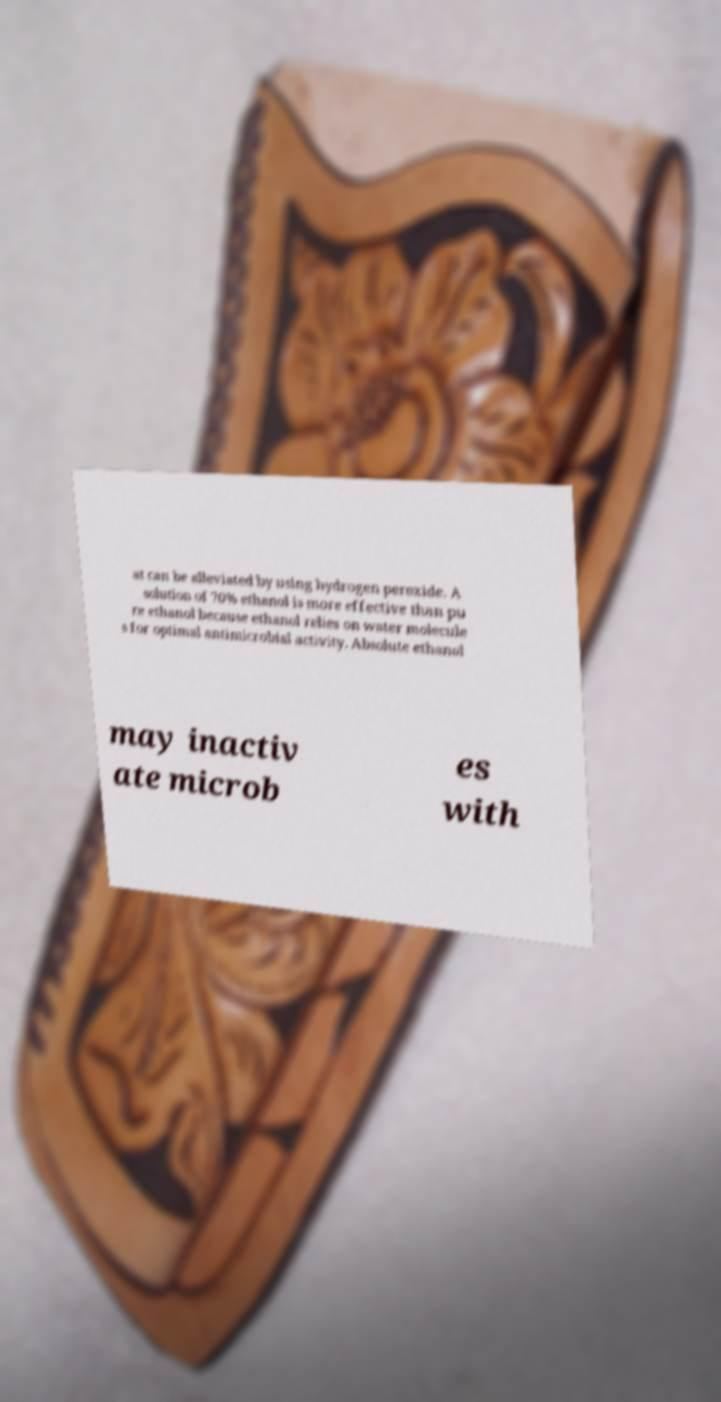Please identify and transcribe the text found in this image. at can be alleviated by using hydrogen peroxide. A solution of 70% ethanol is more effective than pu re ethanol because ethanol relies on water molecule s for optimal antimicrobial activity. Absolute ethanol may inactiv ate microb es with 